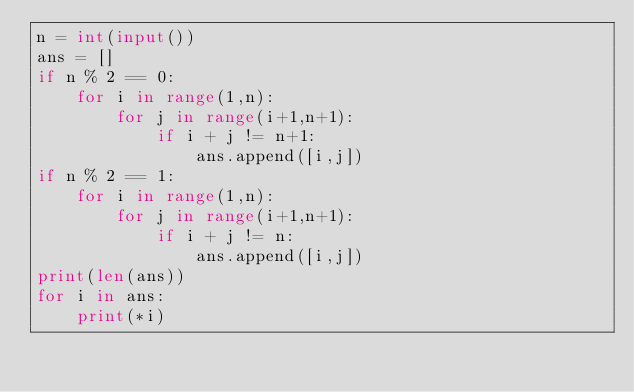<code> <loc_0><loc_0><loc_500><loc_500><_Python_>n = int(input())
ans = []
if n % 2 == 0:
    for i in range(1,n):
        for j in range(i+1,n+1):
            if i + j != n+1:
                ans.append([i,j])
if n % 2 == 1:
    for i in range(1,n):
        for j in range(i+1,n+1):
            if i + j != n:
                ans.append([i,j])    
print(len(ans))
for i in ans:
    print(*i)</code> 